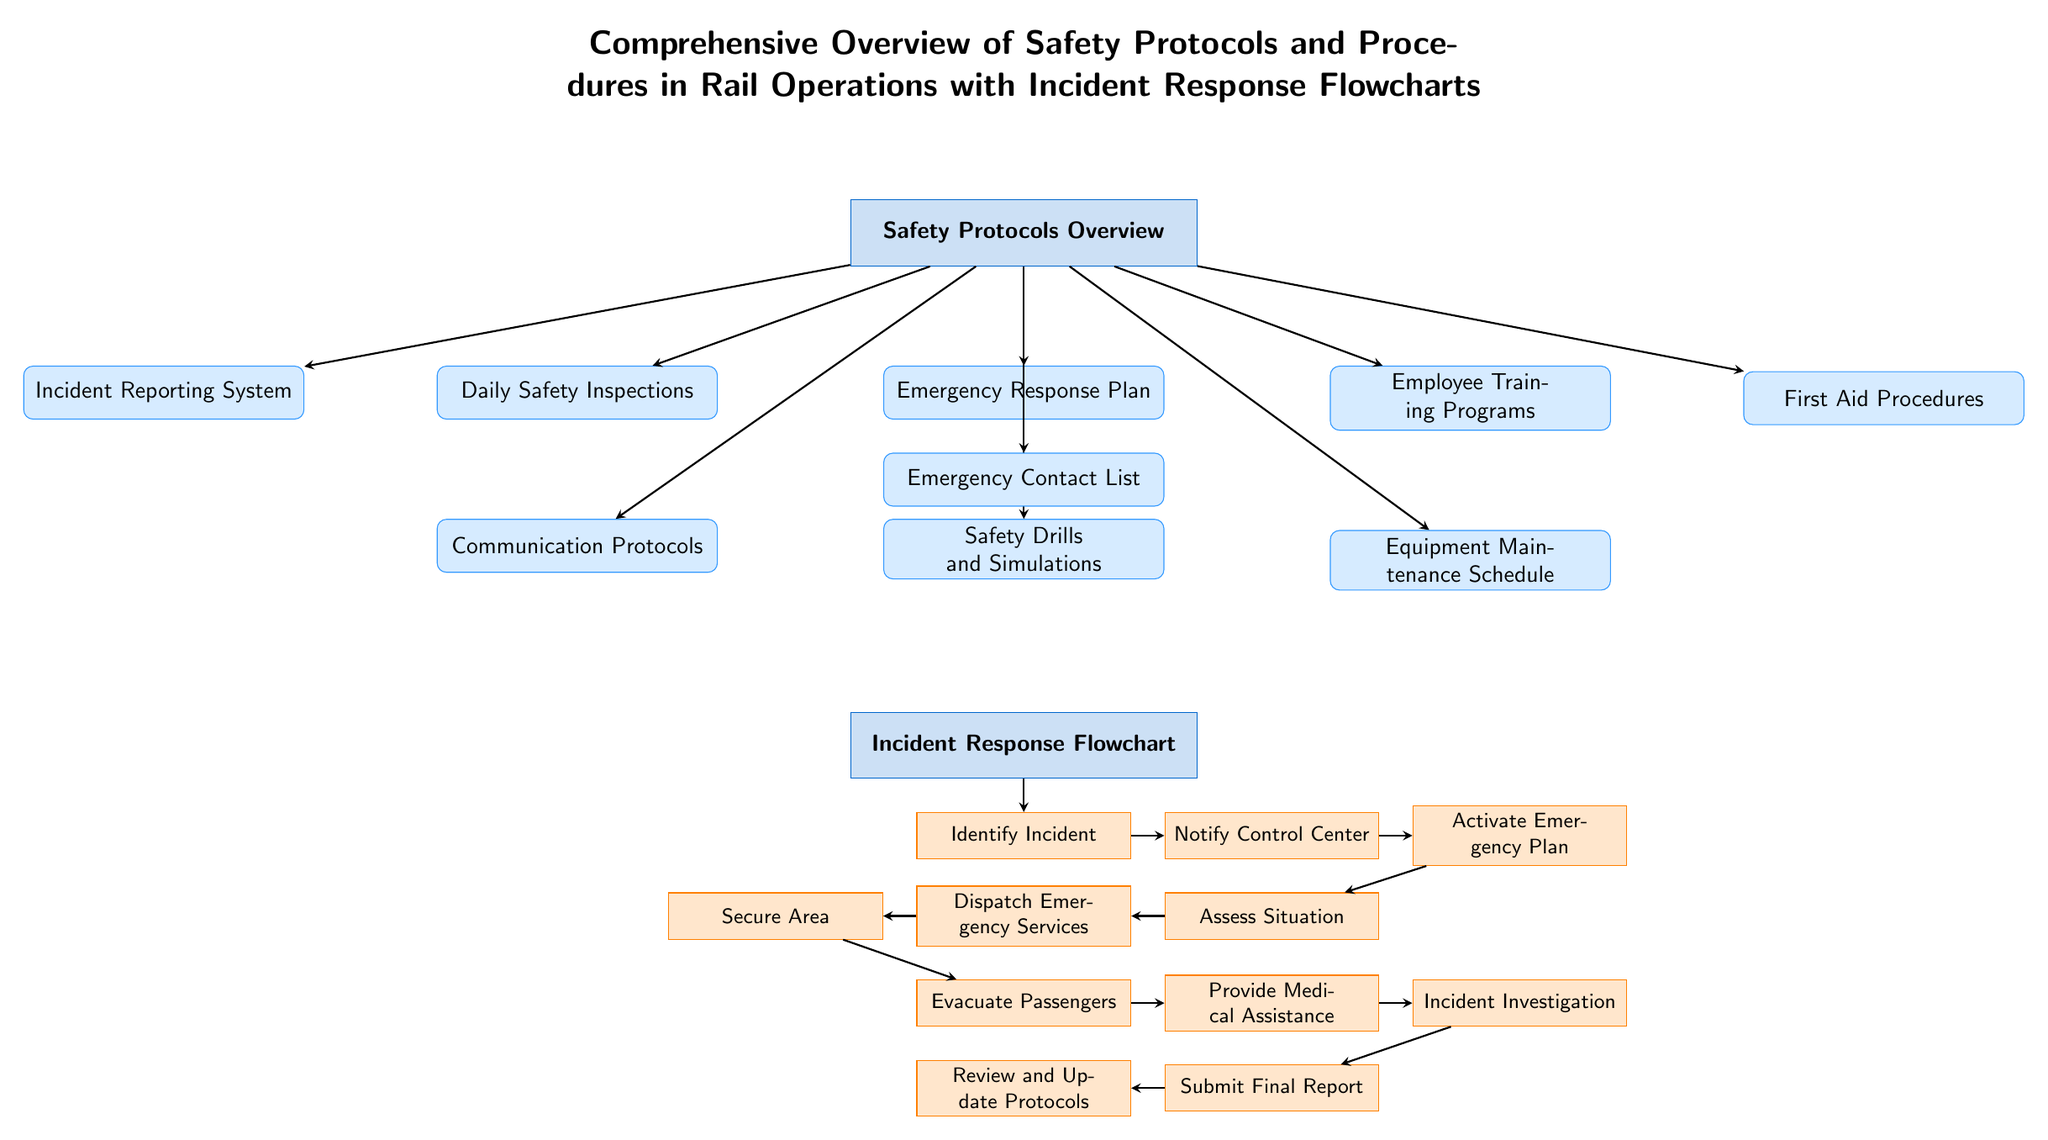What is the main topic of the diagram? The diagram's main topic is indicated at the top, stating "Comprehensive Overview of Safety Protocols and Procedures in Rail Operations with Incident Response Flowcharts."
Answer: Safety Protocols Overview How many sub-nodes come directly under the main node? There are four sub-nodes listed directly below the main node "Safety Protocols Overview," which represent various safety protocols.
Answer: Four Which sub-node is related to training programs? The sub-node concerning training programs is labeled "Employee Training Programs," which is situated to the right of the main node.
Answer: Employee Training Programs What is the first step in the Incident Response Flowchart? The first step in the Incident Response Flowchart is shown as "Identify Incident," located directly below the main node for the flowchart.
Answer: Identify Incident What follows immediately after "Assess Situation" in the Flowchart? Right after "Assess Situation," the flowchart indicates "Dispatch Emergency Services," showing the next action to take.
Answer: Dispatch Emergency Services How many arrows are used to connect nodes to the main safety protocols node? There are a total of six arrows that connect the eight sub-nodes to the main node "Safety Protocols Overview."
Answer: Six What is the last step in the Incident Response Flowchart? The final step in the Incident Response Flowchart is labeled "Review and Update Protocols," which appears at the bottom of the flowchart section.
Answer: Review and Update Protocols Which sub-node comes before "First Aid Procedures"? The sub-node that comes before "First Aid Procedures" in the layout is "Employee Training Programs," as it is located to the left of it.
Answer: Employee Training Programs What type of node is "Emergency Contact List"? "Emergency Contact List" is categorized as a sub-node, as it is connected to the "Emergency Response Plan" sub-node below.
Answer: Sub-node 